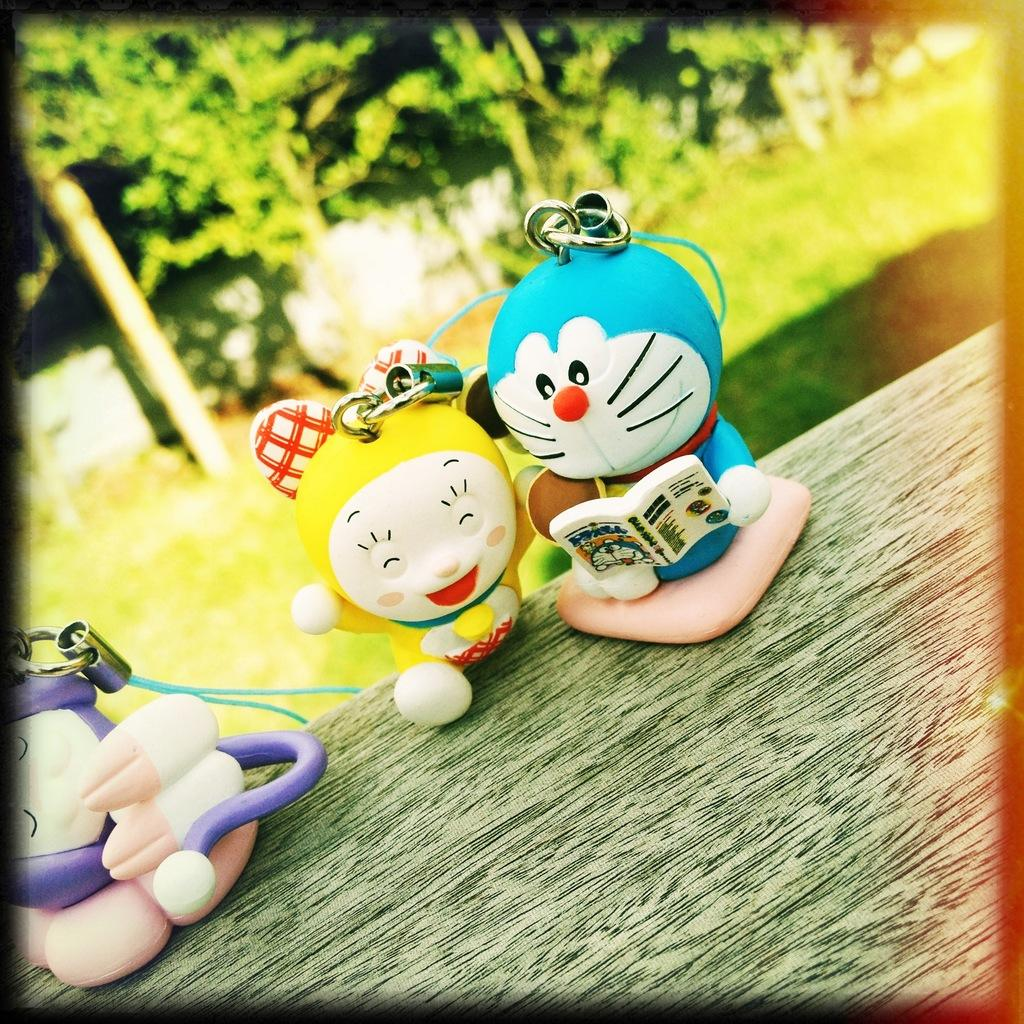What objects can be seen on the wooden surface in the foreground of the image? There are toys on a wooden surface in the foreground of the image. What type of natural environment is visible in the background of the image? There is grassland and trees in the background of the image. How many pigs are serving the toys in the image? There are no pigs or servants present in the image. What scientific theory can be observed in the image? There is no scientific theory depicted in the image; it features toys on a wooden surface and a grassland background with trees. 